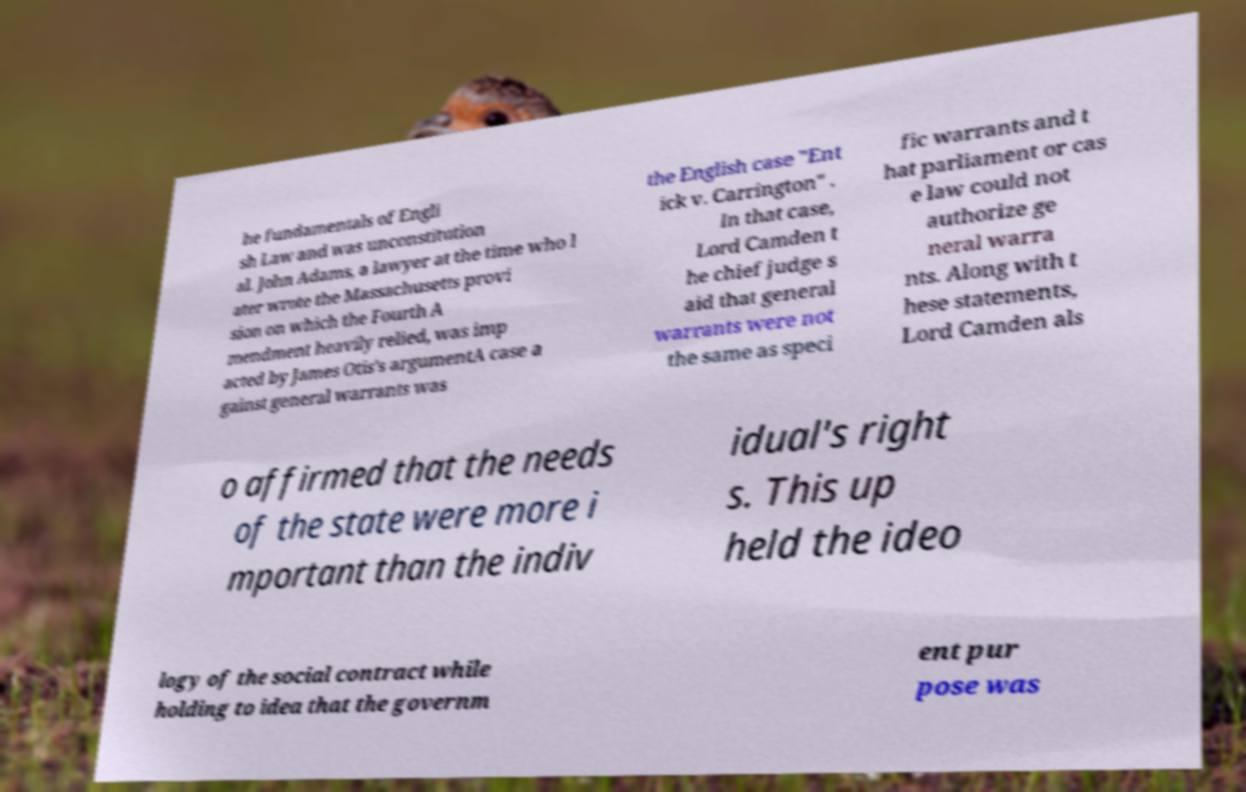Can you read and provide the text displayed in the image?This photo seems to have some interesting text. Can you extract and type it out for me? he fundamentals of Engli sh Law and was unconstitution al. John Adams, a lawyer at the time who l ater wrote the Massachusetts provi sion on which the Fourth A mendment heavily relied, was imp acted by James Otis's argumentA case a gainst general warrants was the English case "Ent ick v. Carrington" . In that case, Lord Camden t he chief judge s aid that general warrants were not the same as speci fic warrants and t hat parliament or cas e law could not authorize ge neral warra nts. Along with t hese statements, Lord Camden als o affirmed that the needs of the state were more i mportant than the indiv idual's right s. This up held the ideo logy of the social contract while holding to idea that the governm ent pur pose was 